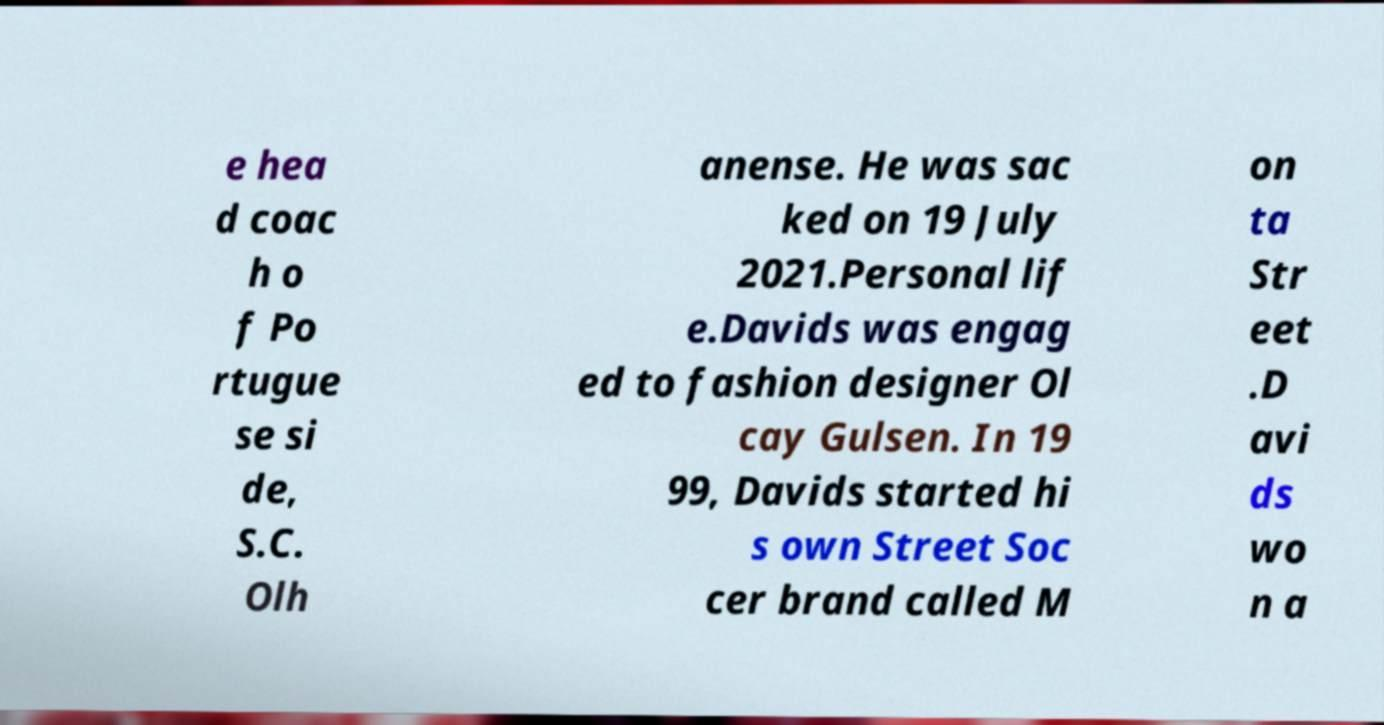There's text embedded in this image that I need extracted. Can you transcribe it verbatim? e hea d coac h o f Po rtugue se si de, S.C. Olh anense. He was sac ked on 19 July 2021.Personal lif e.Davids was engag ed to fashion designer Ol cay Gulsen. In 19 99, Davids started hi s own Street Soc cer brand called M on ta Str eet .D avi ds wo n a 